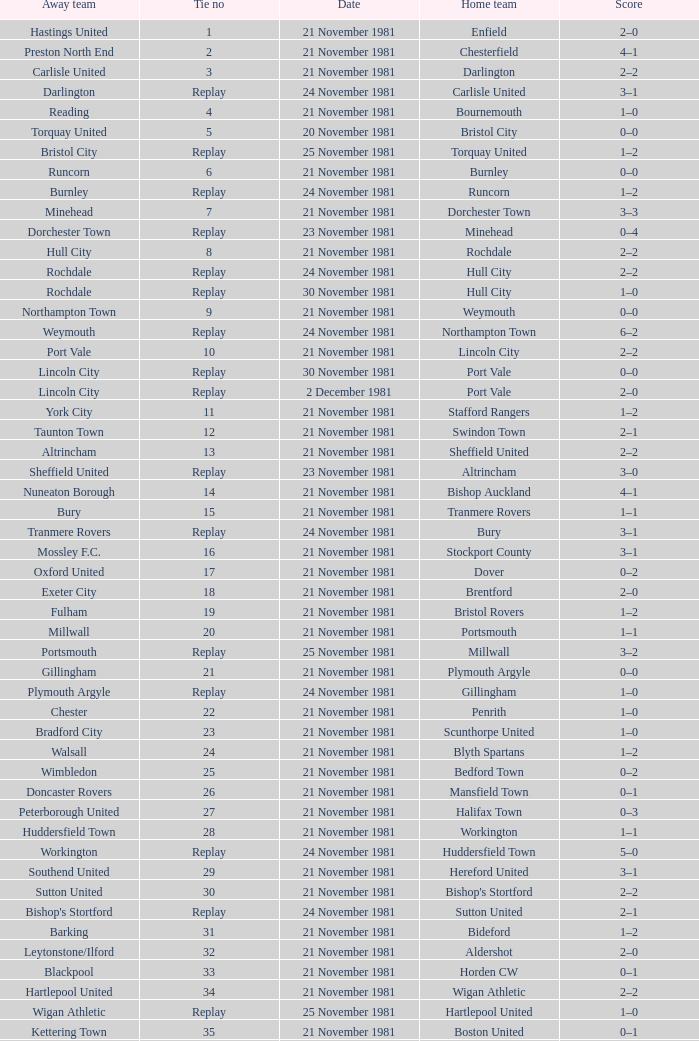Can you give me this table as a dict? {'header': ['Away team', 'Tie no', 'Date', 'Home team', 'Score'], 'rows': [['Hastings United', '1', '21 November 1981', 'Enfield', '2–0'], ['Preston North End', '2', '21 November 1981', 'Chesterfield', '4–1'], ['Carlisle United', '3', '21 November 1981', 'Darlington', '2–2'], ['Darlington', 'Replay', '24 November 1981', 'Carlisle United', '3–1'], ['Reading', '4', '21 November 1981', 'Bournemouth', '1–0'], ['Torquay United', '5', '20 November 1981', 'Bristol City', '0–0'], ['Bristol City', 'Replay', '25 November 1981', 'Torquay United', '1–2'], ['Runcorn', '6', '21 November 1981', 'Burnley', '0–0'], ['Burnley', 'Replay', '24 November 1981', 'Runcorn', '1–2'], ['Minehead', '7', '21 November 1981', 'Dorchester Town', '3–3'], ['Dorchester Town', 'Replay', '23 November 1981', 'Minehead', '0–4'], ['Hull City', '8', '21 November 1981', 'Rochdale', '2–2'], ['Rochdale', 'Replay', '24 November 1981', 'Hull City', '2–2'], ['Rochdale', 'Replay', '30 November 1981', 'Hull City', '1–0'], ['Northampton Town', '9', '21 November 1981', 'Weymouth', '0–0'], ['Weymouth', 'Replay', '24 November 1981', 'Northampton Town', '6–2'], ['Port Vale', '10', '21 November 1981', 'Lincoln City', '2–2'], ['Lincoln City', 'Replay', '30 November 1981', 'Port Vale', '0–0'], ['Lincoln City', 'Replay', '2 December 1981', 'Port Vale', '2–0'], ['York City', '11', '21 November 1981', 'Stafford Rangers', '1–2'], ['Taunton Town', '12', '21 November 1981', 'Swindon Town', '2–1'], ['Altrincham', '13', '21 November 1981', 'Sheffield United', '2–2'], ['Sheffield United', 'Replay', '23 November 1981', 'Altrincham', '3–0'], ['Nuneaton Borough', '14', '21 November 1981', 'Bishop Auckland', '4–1'], ['Bury', '15', '21 November 1981', 'Tranmere Rovers', '1–1'], ['Tranmere Rovers', 'Replay', '24 November 1981', 'Bury', '3–1'], ['Mossley F.C.', '16', '21 November 1981', 'Stockport County', '3–1'], ['Oxford United', '17', '21 November 1981', 'Dover', '0–2'], ['Exeter City', '18', '21 November 1981', 'Brentford', '2–0'], ['Fulham', '19', '21 November 1981', 'Bristol Rovers', '1–2'], ['Millwall', '20', '21 November 1981', 'Portsmouth', '1–1'], ['Portsmouth', 'Replay', '25 November 1981', 'Millwall', '3–2'], ['Gillingham', '21', '21 November 1981', 'Plymouth Argyle', '0–0'], ['Plymouth Argyle', 'Replay', '24 November 1981', 'Gillingham', '1–0'], ['Chester', '22', '21 November 1981', 'Penrith', '1–0'], ['Bradford City', '23', '21 November 1981', 'Scunthorpe United', '1–0'], ['Walsall', '24', '21 November 1981', 'Blyth Spartans', '1–2'], ['Wimbledon', '25', '21 November 1981', 'Bedford Town', '0–2'], ['Doncaster Rovers', '26', '21 November 1981', 'Mansfield Town', '0–1'], ['Peterborough United', '27', '21 November 1981', 'Halifax Town', '0–3'], ['Huddersfield Town', '28', '21 November 1981', 'Workington', '1–1'], ['Workington', 'Replay', '24 November 1981', 'Huddersfield Town', '5–0'], ['Southend United', '29', '21 November 1981', 'Hereford United', '3–1'], ['Sutton United', '30', '21 November 1981', "Bishop's Stortford", '2–2'], ["Bishop's Stortford", 'Replay', '24 November 1981', 'Sutton United', '2–1'], ['Barking', '31', '21 November 1981', 'Bideford', '1–2'], ['Leytonstone/Ilford', '32', '21 November 1981', 'Aldershot', '2–0'], ['Blackpool', '33', '21 November 1981', 'Horden CW', '0–1'], ['Hartlepool United', '34', '21 November 1981', 'Wigan Athletic', '2–2'], ['Wigan Athletic', 'Replay', '25 November 1981', 'Hartlepool United', '1–0'], ['Kettering Town', '35', '21 November 1981', 'Boston United', '0–1'], ['Barnet', '36', '21 November 1981', 'Harlow Town', '0–0'], ['Harlow Town', 'Replay', '24 November 1981', 'Barnet', '1–0'], ['Newport County', '37', '21 November 1981', 'Colchester United', '2–0'], ['Wycombe Wanderers', '38', '21 November 1981', 'Hendon', '1–1'], ['Hendon', 'Replay', '24 November 1981', 'Wycombe Wanderers', '2–0'], ['Yeovil Town', '39', '21 November 1981', 'Dagenham', '2–2'], ['Dagenham', 'Replay', '25 November 1981', 'Yeovil Town', '0–1'], ['Crewe Alexandra', '40', '21 November 1981', 'Willenhall Town', '0–1']]} Minehead has what tie number? Replay. 